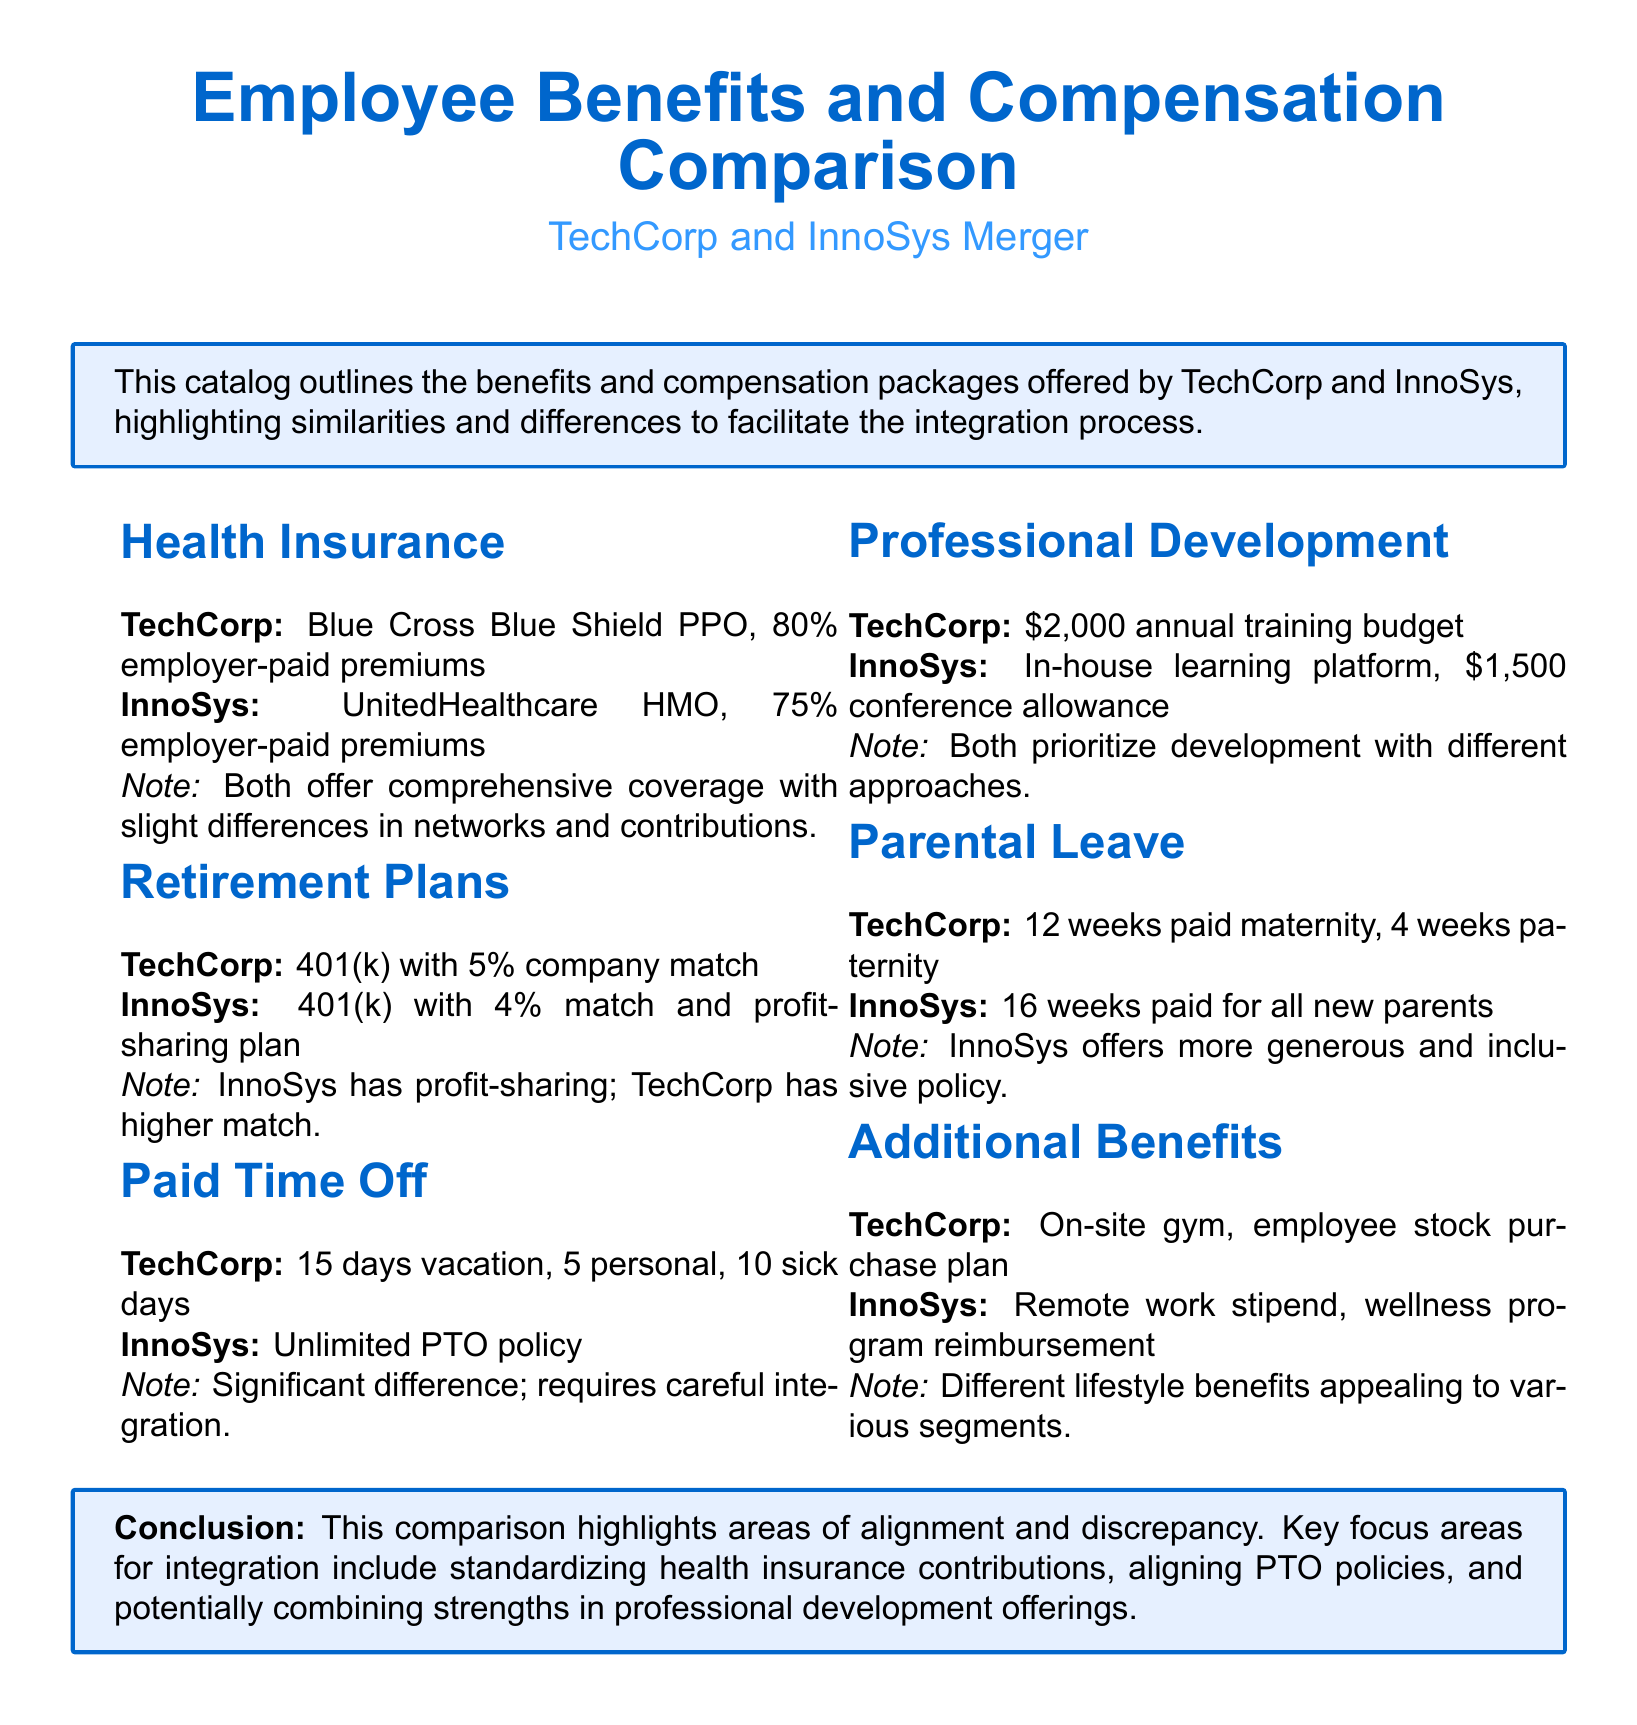What health insurance provider does TechCorp use? The document specifies that TechCorp uses Blue Cross Blue Shield PPO for health insurance.
Answer: Blue Cross Blue Shield PPO What percentage of premiums are employer-paid by InnoSys? InnoSys has 75% of premiums employer-paid according to the document.
Answer: 75% What is the company match percentage for TechCorp’s 401(k) plan? TechCorp offers a 5% company match on its 401(k) plan as stated in the document.
Answer: 5% How many paid vacation days does TechCorp provide? TechCorp provides 15 days of vacation, as mentioned in the paid time off section.
Answer: 15 days Which company offers a profit-sharing plan in their retirement benefits? The document indicates that InnoSys includes a profit-sharing plan in their retirement benefits.
Answer: InnoSys Which company has a more generous parental leave policy? The comparison notes that InnoSys has a more generous parental leave policy than TechCorp.
Answer: InnoSys What is TechCorp’s annual budget for professional development? According to the document, TechCorp allocates $2,000 annually for professional development.
Answer: $2,000 What is a significant difference in paid time off policies between the two companies? The document highlights that TechCorp has a fixed PTO policy, while InnoSys offers an unlimited PTO policy.
Answer: Unlimited PTO policy Which additional benefit is unique to InnoSys? The document states that InnoSys offers a remote work stipend, which is not mentioned for TechCorp.
Answer: Remote work stipend 